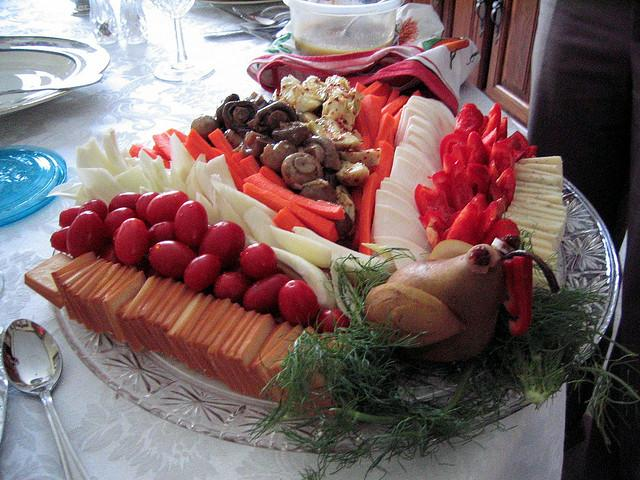What kind of food is between the mushrooms and carrots? Please explain your reasoning. vegetable. All of the items on the plate are mostly vegetables. 